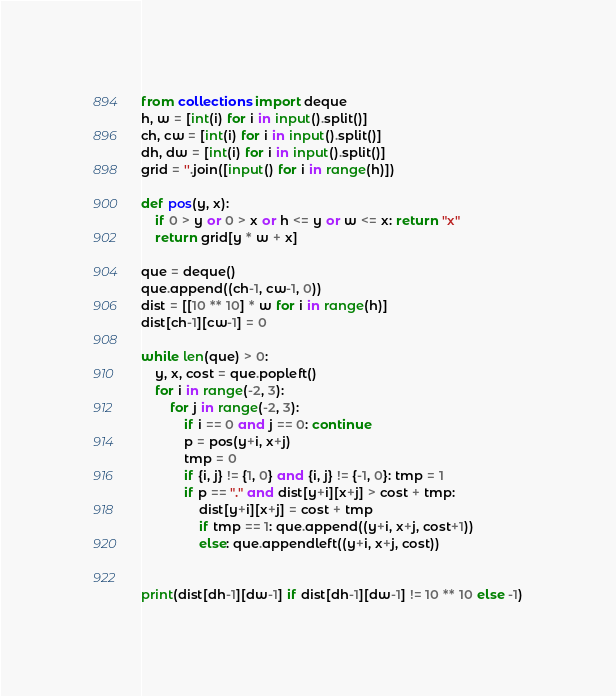<code> <loc_0><loc_0><loc_500><loc_500><_Python_>from collections import deque
h, w = [int(i) for i in input().split()]
ch, cw = [int(i) for i in input().split()]
dh, dw = [int(i) for i in input().split()]
grid = ''.join([input() for i in range(h)])

def pos(y, x):
    if 0 > y or 0 > x or h <= y or w <= x: return "x"
    return grid[y * w + x]

que = deque()
que.append((ch-1, cw-1, 0))
dist = [[10 ** 10] * w for i in range(h)]
dist[ch-1][cw-1] = 0

while len(que) > 0:
    y, x, cost = que.popleft()
    for i in range(-2, 3):
        for j in range(-2, 3):
            if i == 0 and j == 0: continue
            p = pos(y+i, x+j)
            tmp = 0
            if {i, j} != {1, 0} and {i, j} != {-1, 0}: tmp = 1
            if p == "." and dist[y+i][x+j] > cost + tmp:
                dist[y+i][x+j] = cost + tmp
                if tmp == 1: que.append((y+i, x+j, cost+1))
                else: que.appendleft((y+i, x+j, cost))
                

print(dist[dh-1][dw-1] if dist[dh-1][dw-1] != 10 ** 10 else -1)</code> 